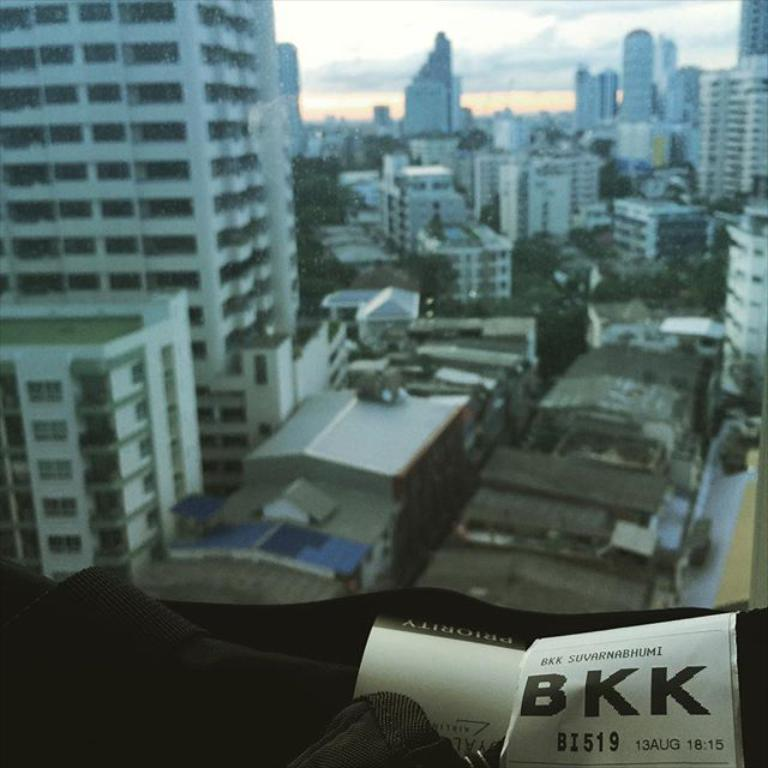What type of structures can be seen in the image? There are buildings in the image. What other natural elements are present in the image? There are trees in the image. What is visible at the top of the image? The sky is visible at the top of the image. What color is the object at the bottom of the image? The object at the bottom of the image is black. What idea does the scent of the trees in the image represent? There is no mention of a scent in the image, and therefore no idea can be associated with it. 